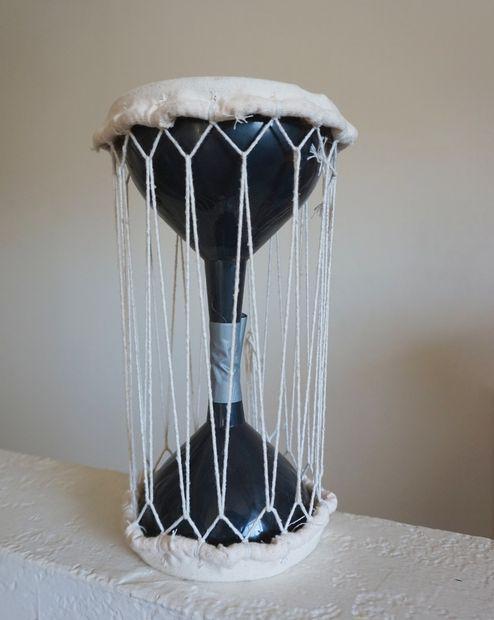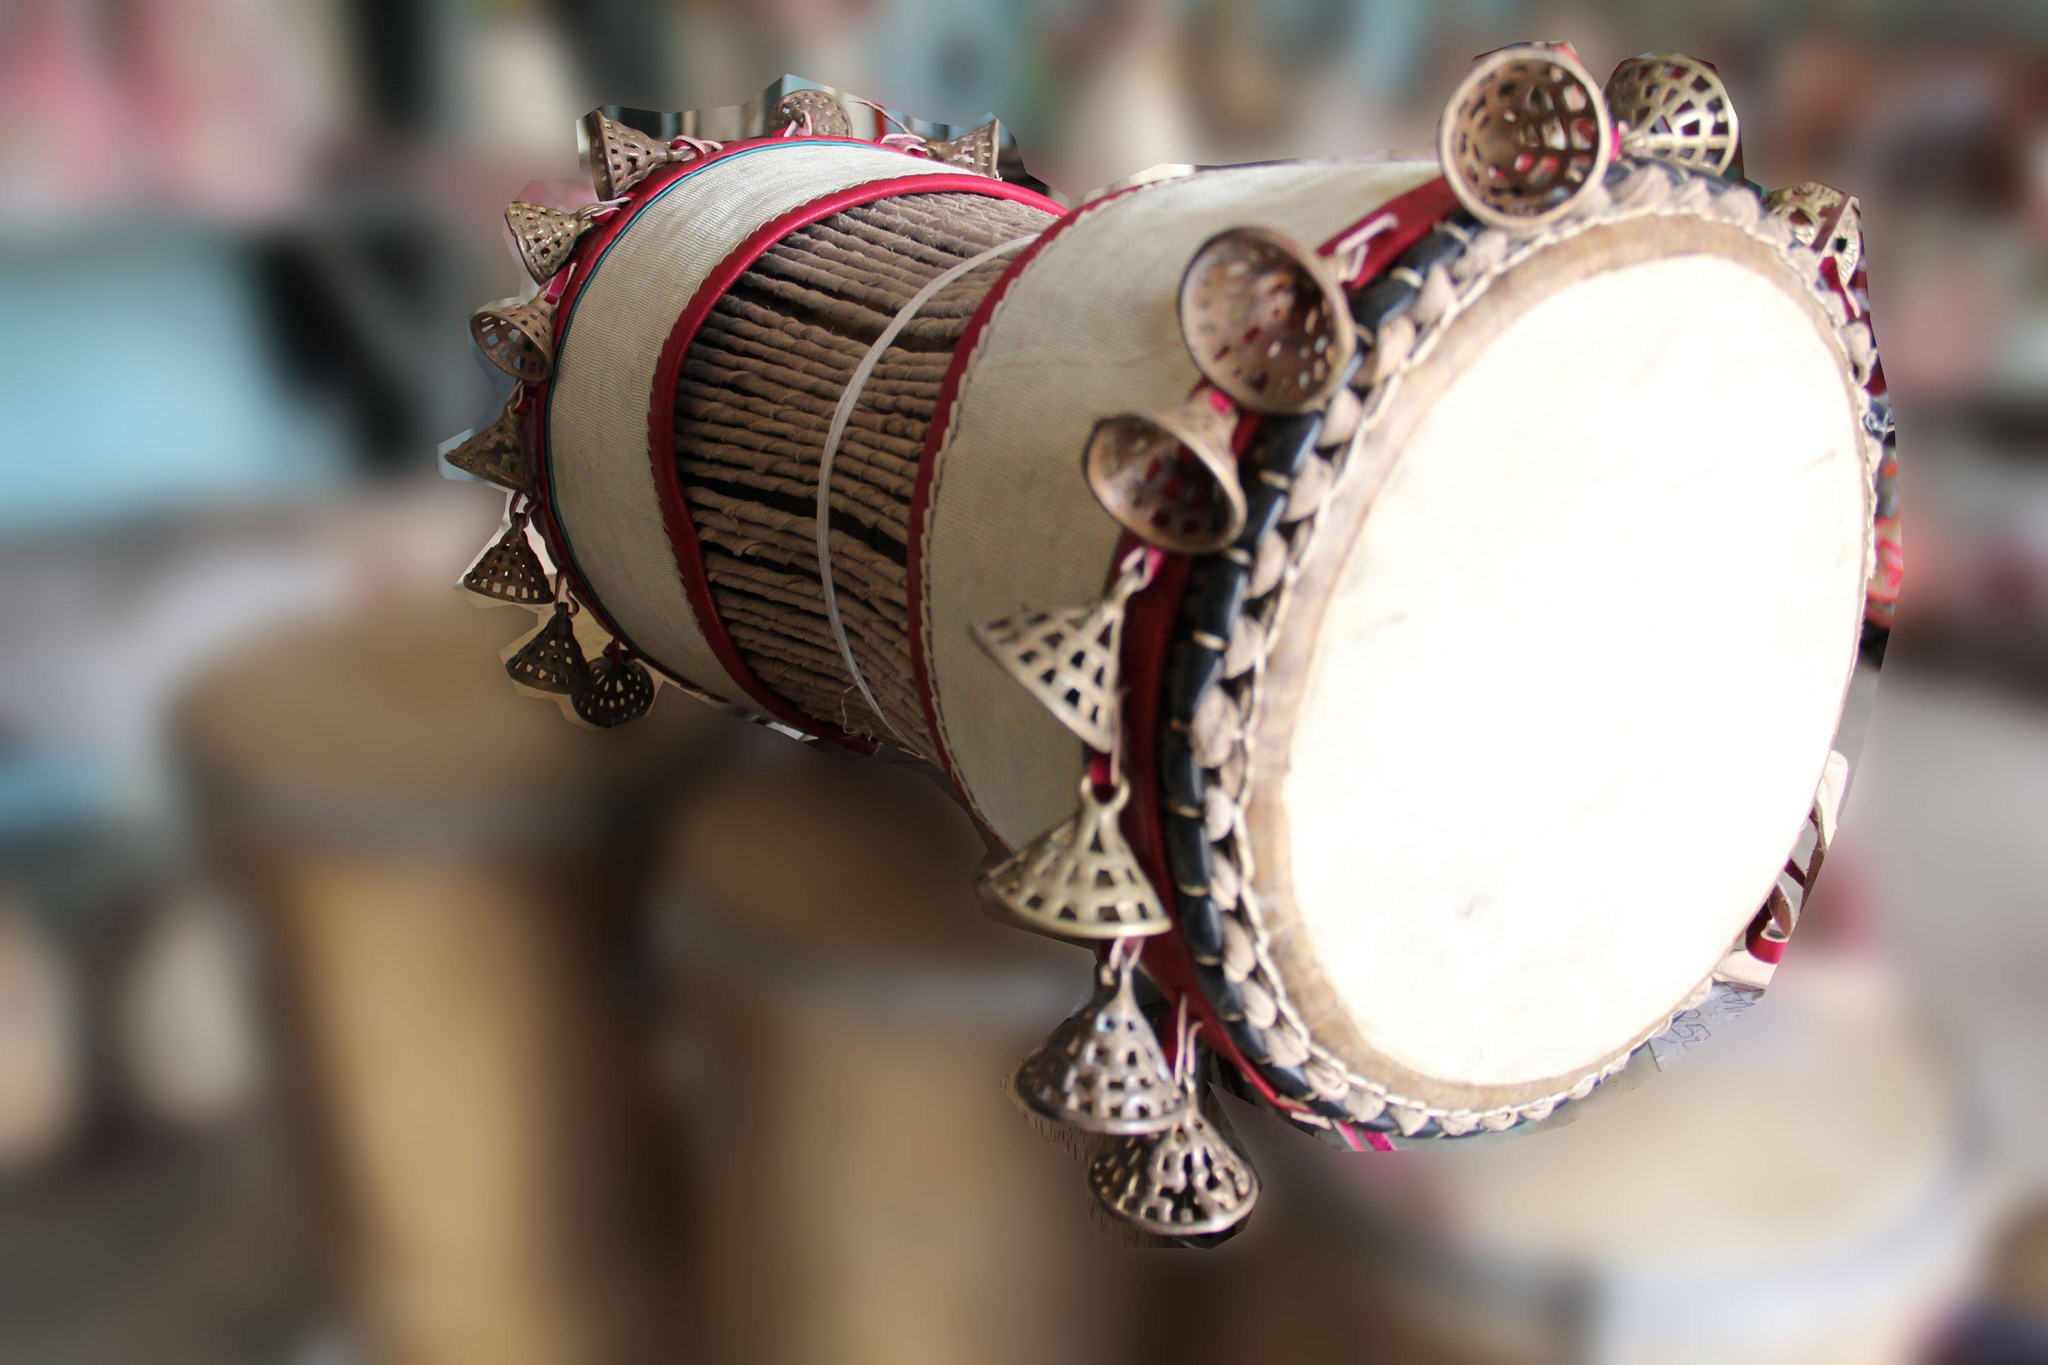The first image is the image on the left, the second image is the image on the right. Given the left and right images, does the statement "The drums in each image are standing upright." hold true? Answer yes or no. No. The first image is the image on the left, the second image is the image on the right. For the images shown, is this caption "The left and right image contains the same number of drums." true? Answer yes or no. Yes. 